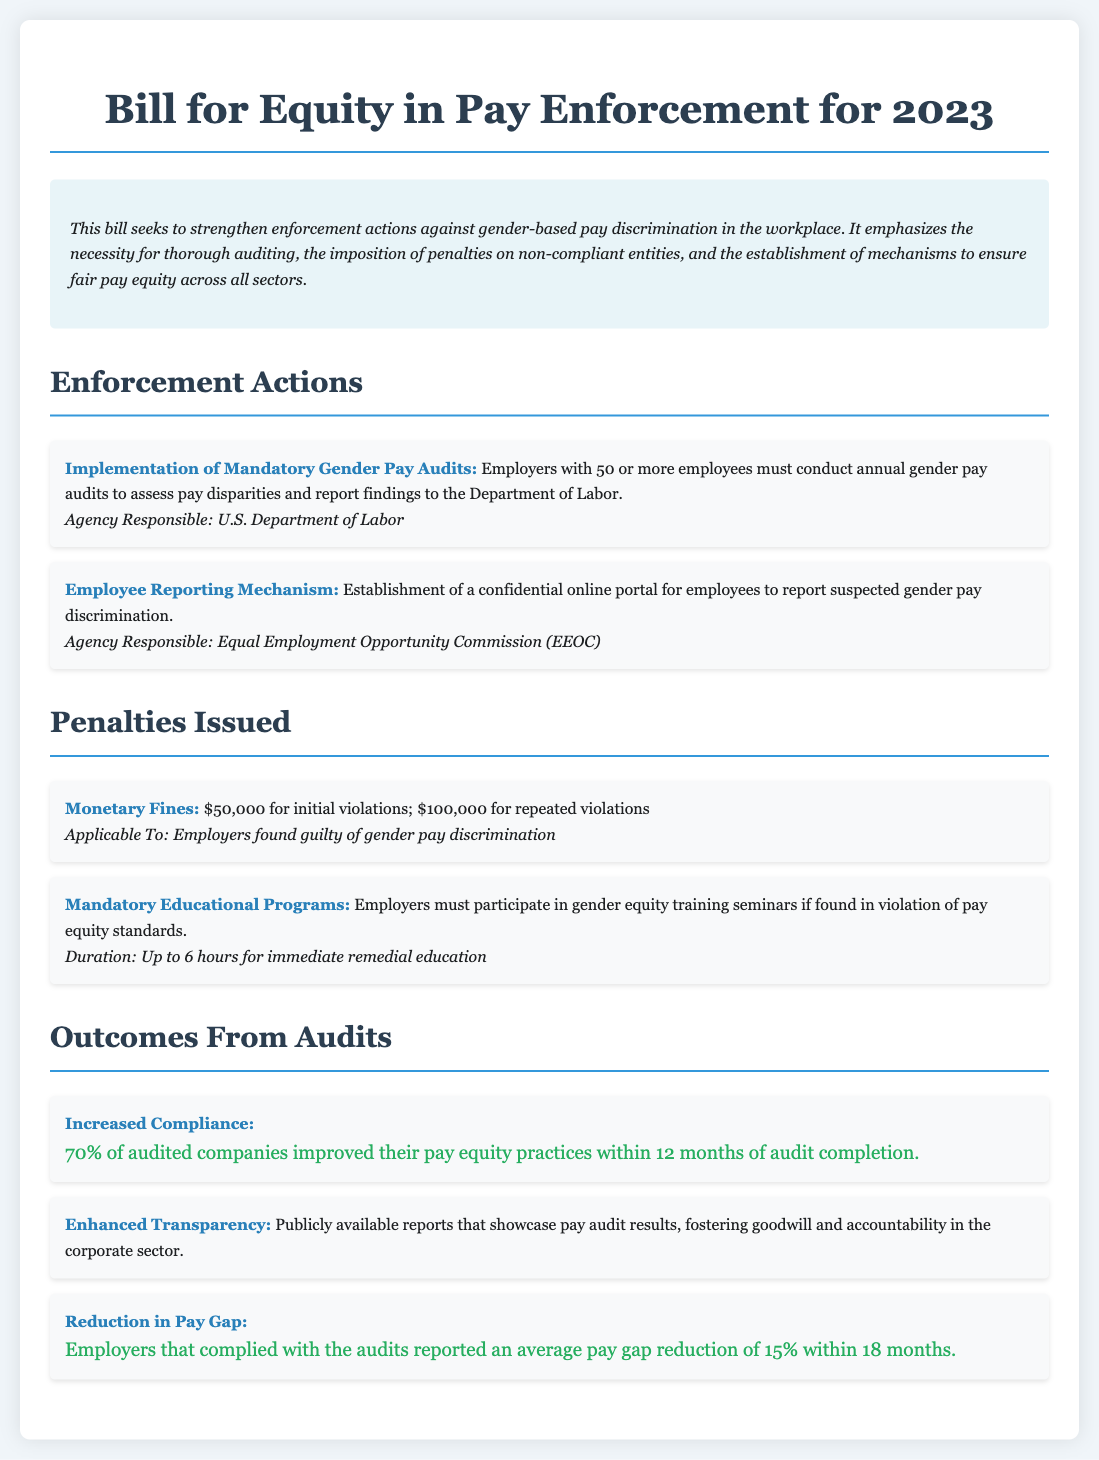what is the penalty for initial violations? The document states that the monetary fine for initial violations is $50,000.
Answer: $50,000 how often must employers conduct gender pay audits? The document indicates that employers with 50 or more employees must conduct annual gender pay audits.
Answer: annual which agency is responsible for implementing mandatory gender pay audits? The U.S. Department of Labor is responsible for implementing mandatory gender pay audits.
Answer: U.S. Department of Labor what percentage of audited companies improved their pay equity practices? The document mentions that 70% of audited companies improved their pay equity practices within 12 months.
Answer: 70% what is the duration of mandatory educational programs for employers found in violation? The duration of mandatory educational programs for employers found in violation is up to 6 hours.
Answer: up to 6 hours what is the average pay gap reduction reported by compliant employers? Employers that complied with the audits reported an average pay gap reduction of 15%.
Answer: 15% what type of mechanism was established for employee reporting? The document describes the establishment of a confidential online portal for employees to report suspected gender pay discrimination.
Answer: confidential online portal how much is the penalty for repeated violations? The document states that the penalty for repeated violations is $100,000.
Answer: $100,000 what is a required action for non-compliant employers? Non-compliant employers must participate in gender equity training seminars.
Answer: participate in gender equity training seminars 